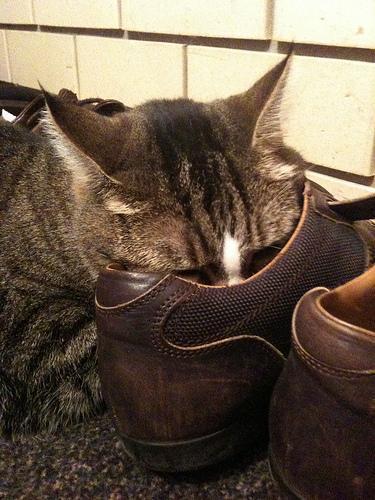How many shoes are there?
Give a very brief answer. 2. How many cats are there?
Give a very brief answer. 1. How many shoes?
Give a very brief answer. 2. How many cats?
Give a very brief answer. 1. How many ears does the cat have?
Give a very brief answer. 2. How many shoes are in the picture?
Give a very brief answer. 2. 